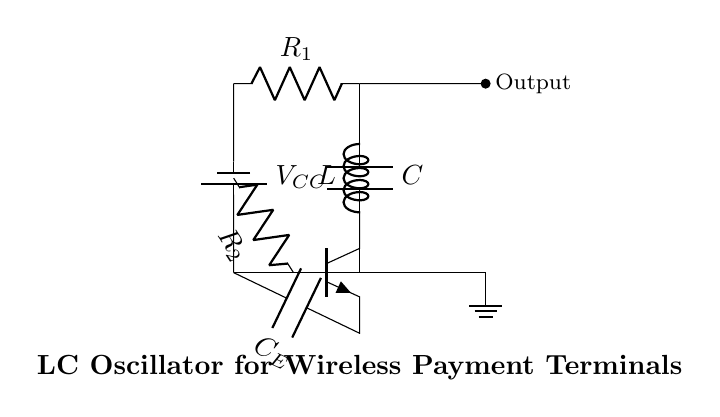What type of circuit is depicted here? The circuit is an LC oscillator circuit, which is characterized by the presence of inductance and capacitance that allow it to generate oscillations.
Answer: LC oscillator What are the main components in the circuit? The main components in the circuit are the inductor, capacitor, transistor, resistors, and power supply. Each plays a specific role in the functioning of the oscillator.
Answer: Inductor, capacitor, transistor, resistors, power supply What is the role of the capacitor labeled C in the circuit? The capacitor labeled C stores energy in the circuit and is essential for generating the oscillations in conjunction with the inductor. It allows the circuit to resonate.
Answer: Energy storage What is the purpose of the transistor in the circuit? The transistor amplifies the signal and helps sustain the oscillations by acting as a switch or signal regulator, contributing to the oscillator's feedback loop.
Answer: Signal amplification What does the resistor labeled R1 do in the circuit? Resistor R1 is used to limit the current flowing into the inductor and capacitor, helping to stabilize the operation of the oscillator by controlling the oscillation amplitude.
Answer: Current limiting How does the LC circuit generate oscillations? The LC circuit generates oscillations through the exchange of energy between the inductor and capacitor. When current flows, the capacitor charges and discharges, which creates an oscillating voltage.
Answer: Energy exchange 